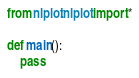<code> <loc_0><loc_0><loc_500><loc_500><_Python_>from nlplot.nlplot import *

def main():
    pass
</code> 